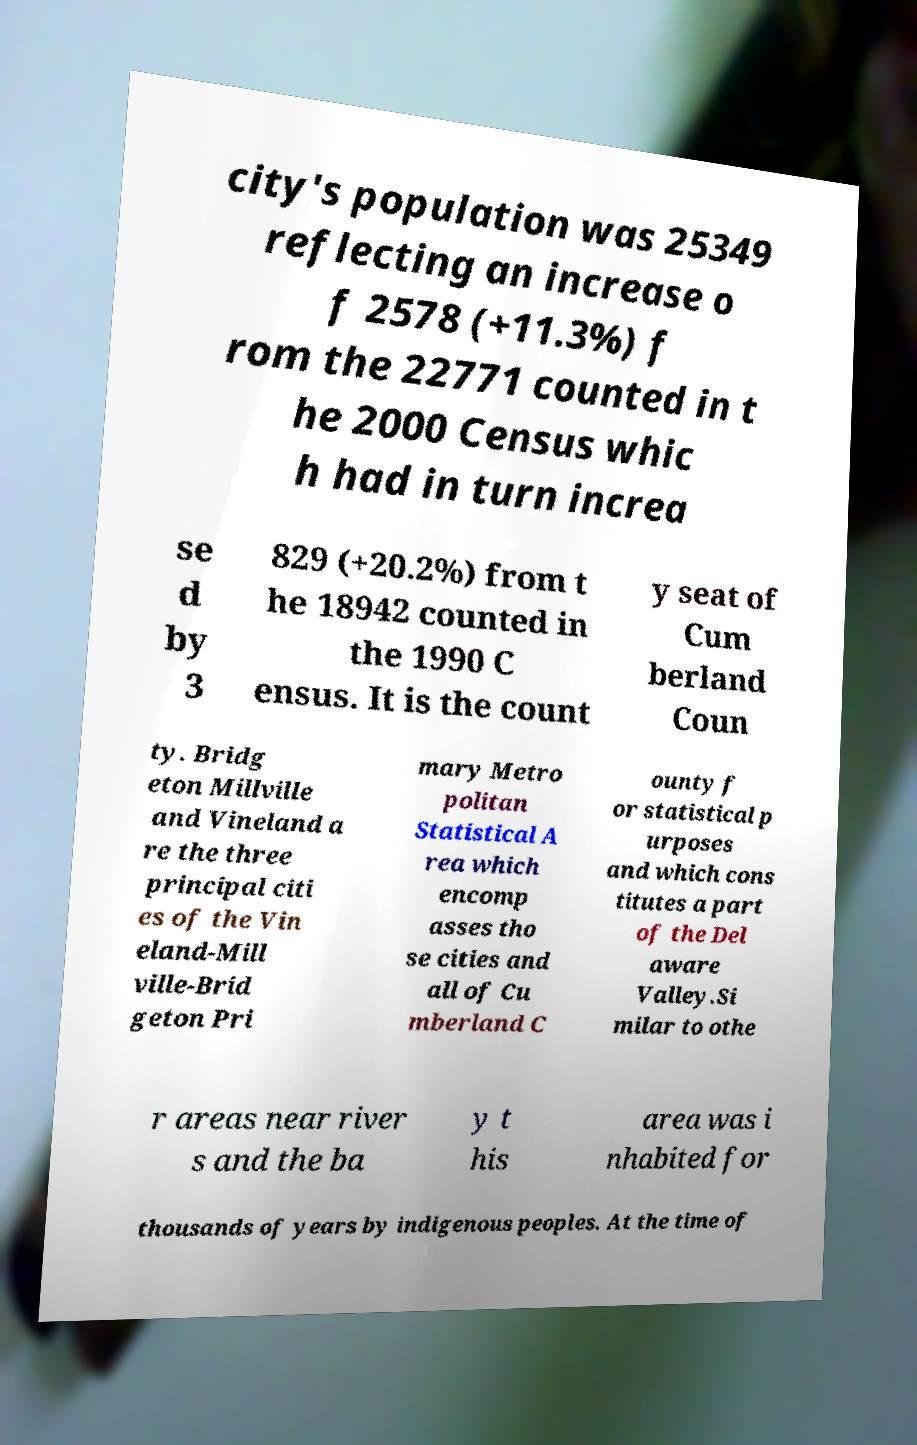I need the written content from this picture converted into text. Can you do that? city's population was 25349 reflecting an increase o f 2578 (+11.3%) f rom the 22771 counted in t he 2000 Census whic h had in turn increa se d by 3 829 (+20.2%) from t he 18942 counted in the 1990 C ensus. It is the count y seat of Cum berland Coun ty. Bridg eton Millville and Vineland a re the three principal citi es of the Vin eland-Mill ville-Brid geton Pri mary Metro politan Statistical A rea which encomp asses tho se cities and all of Cu mberland C ounty f or statistical p urposes and which cons titutes a part of the Del aware Valley.Si milar to othe r areas near river s and the ba y t his area was i nhabited for thousands of years by indigenous peoples. At the time of 